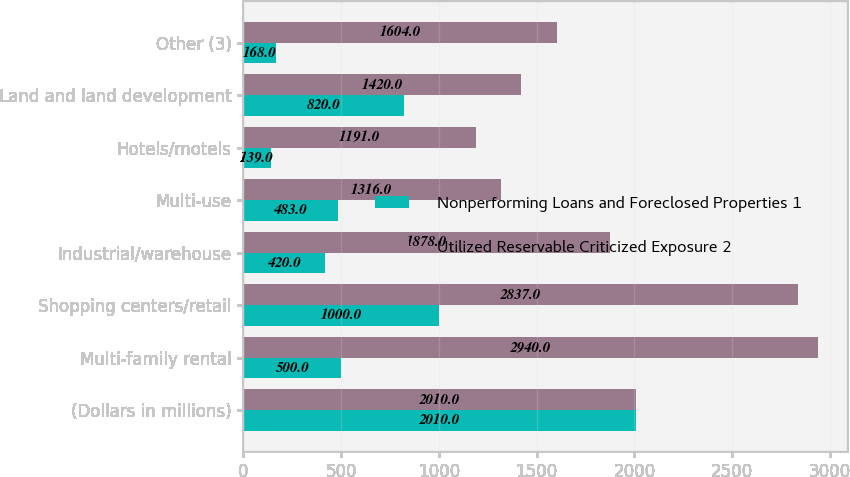<chart> <loc_0><loc_0><loc_500><loc_500><stacked_bar_chart><ecel><fcel>(Dollars in millions)<fcel>Multi-family rental<fcel>Shopping centers/retail<fcel>Industrial/warehouse<fcel>Multi-use<fcel>Hotels/motels<fcel>Land and land development<fcel>Other (3)<nl><fcel>Nonperforming Loans and Foreclosed Properties 1<fcel>2010<fcel>500<fcel>1000<fcel>420<fcel>483<fcel>139<fcel>820<fcel>168<nl><fcel>Utilized Reservable Criticized Exposure 2<fcel>2010<fcel>2940<fcel>2837<fcel>1878<fcel>1316<fcel>1191<fcel>1420<fcel>1604<nl></chart> 